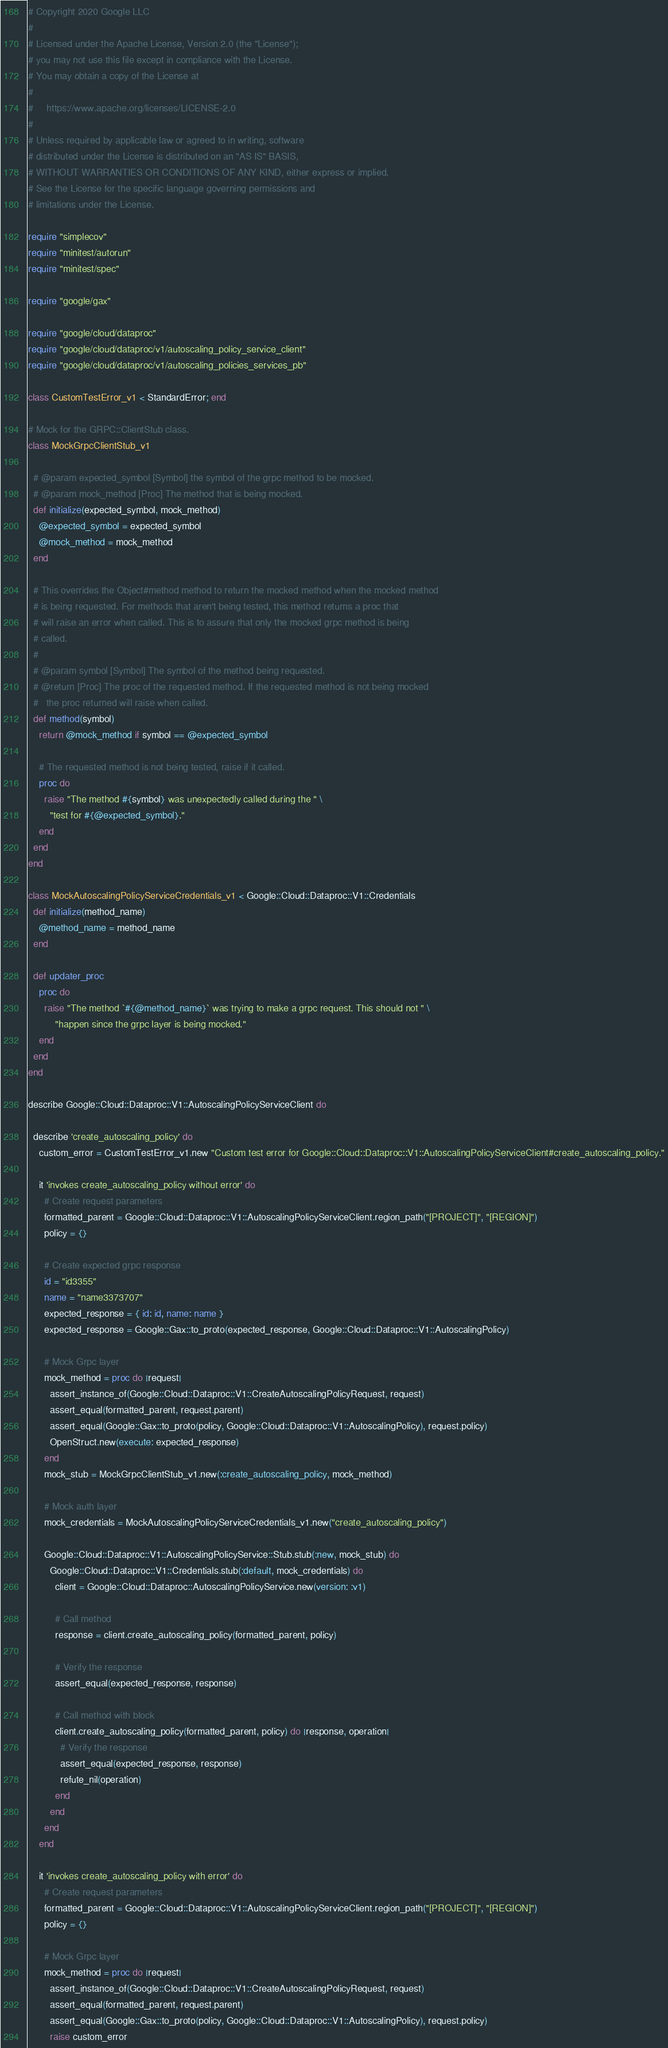Convert code to text. <code><loc_0><loc_0><loc_500><loc_500><_Ruby_># Copyright 2020 Google LLC
#
# Licensed under the Apache License, Version 2.0 (the "License");
# you may not use this file except in compliance with the License.
# You may obtain a copy of the License at
#
#     https://www.apache.org/licenses/LICENSE-2.0
#
# Unless required by applicable law or agreed to in writing, software
# distributed under the License is distributed on an "AS IS" BASIS,
# WITHOUT WARRANTIES OR CONDITIONS OF ANY KIND, either express or implied.
# See the License for the specific language governing permissions and
# limitations under the License.

require "simplecov"
require "minitest/autorun"
require "minitest/spec"

require "google/gax"

require "google/cloud/dataproc"
require "google/cloud/dataproc/v1/autoscaling_policy_service_client"
require "google/cloud/dataproc/v1/autoscaling_policies_services_pb"

class CustomTestError_v1 < StandardError; end

# Mock for the GRPC::ClientStub class.
class MockGrpcClientStub_v1

  # @param expected_symbol [Symbol] the symbol of the grpc method to be mocked.
  # @param mock_method [Proc] The method that is being mocked.
  def initialize(expected_symbol, mock_method)
    @expected_symbol = expected_symbol
    @mock_method = mock_method
  end

  # This overrides the Object#method method to return the mocked method when the mocked method
  # is being requested. For methods that aren't being tested, this method returns a proc that
  # will raise an error when called. This is to assure that only the mocked grpc method is being
  # called.
  #
  # @param symbol [Symbol] The symbol of the method being requested.
  # @return [Proc] The proc of the requested method. If the requested method is not being mocked
  #   the proc returned will raise when called.
  def method(symbol)
    return @mock_method if symbol == @expected_symbol

    # The requested method is not being tested, raise if it called.
    proc do
      raise "The method #{symbol} was unexpectedly called during the " \
        "test for #{@expected_symbol}."
    end
  end
end

class MockAutoscalingPolicyServiceCredentials_v1 < Google::Cloud::Dataproc::V1::Credentials
  def initialize(method_name)
    @method_name = method_name
  end

  def updater_proc
    proc do
      raise "The method `#{@method_name}` was trying to make a grpc request. This should not " \
          "happen since the grpc layer is being mocked."
    end
  end
end

describe Google::Cloud::Dataproc::V1::AutoscalingPolicyServiceClient do

  describe 'create_autoscaling_policy' do
    custom_error = CustomTestError_v1.new "Custom test error for Google::Cloud::Dataproc::V1::AutoscalingPolicyServiceClient#create_autoscaling_policy."

    it 'invokes create_autoscaling_policy without error' do
      # Create request parameters
      formatted_parent = Google::Cloud::Dataproc::V1::AutoscalingPolicyServiceClient.region_path("[PROJECT]", "[REGION]")
      policy = {}

      # Create expected grpc response
      id = "id3355"
      name = "name3373707"
      expected_response = { id: id, name: name }
      expected_response = Google::Gax::to_proto(expected_response, Google::Cloud::Dataproc::V1::AutoscalingPolicy)

      # Mock Grpc layer
      mock_method = proc do |request|
        assert_instance_of(Google::Cloud::Dataproc::V1::CreateAutoscalingPolicyRequest, request)
        assert_equal(formatted_parent, request.parent)
        assert_equal(Google::Gax::to_proto(policy, Google::Cloud::Dataproc::V1::AutoscalingPolicy), request.policy)
        OpenStruct.new(execute: expected_response)
      end
      mock_stub = MockGrpcClientStub_v1.new(:create_autoscaling_policy, mock_method)

      # Mock auth layer
      mock_credentials = MockAutoscalingPolicyServiceCredentials_v1.new("create_autoscaling_policy")

      Google::Cloud::Dataproc::V1::AutoscalingPolicyService::Stub.stub(:new, mock_stub) do
        Google::Cloud::Dataproc::V1::Credentials.stub(:default, mock_credentials) do
          client = Google::Cloud::Dataproc::AutoscalingPolicyService.new(version: :v1)

          # Call method
          response = client.create_autoscaling_policy(formatted_parent, policy)

          # Verify the response
          assert_equal(expected_response, response)

          # Call method with block
          client.create_autoscaling_policy(formatted_parent, policy) do |response, operation|
            # Verify the response
            assert_equal(expected_response, response)
            refute_nil(operation)
          end
        end
      end
    end

    it 'invokes create_autoscaling_policy with error' do
      # Create request parameters
      formatted_parent = Google::Cloud::Dataproc::V1::AutoscalingPolicyServiceClient.region_path("[PROJECT]", "[REGION]")
      policy = {}

      # Mock Grpc layer
      mock_method = proc do |request|
        assert_instance_of(Google::Cloud::Dataproc::V1::CreateAutoscalingPolicyRequest, request)
        assert_equal(formatted_parent, request.parent)
        assert_equal(Google::Gax::to_proto(policy, Google::Cloud::Dataproc::V1::AutoscalingPolicy), request.policy)
        raise custom_error</code> 